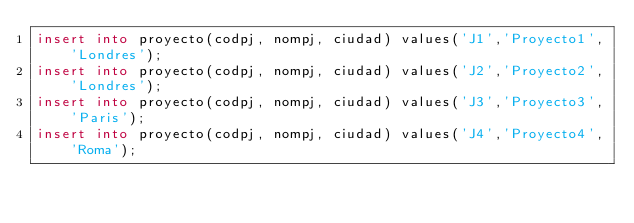<code> <loc_0><loc_0><loc_500><loc_500><_SQL_>insert into proyecto(codpj, nompj, ciudad) values('J1','Proyecto1','Londres');
insert into proyecto(codpj, nompj, ciudad) values('J2','Proyecto2','Londres');
insert into proyecto(codpj, nompj, ciudad) values('J3','Proyecto3','Paris');
insert into proyecto(codpj, nompj, ciudad) values('J4','Proyecto4','Roma');</code> 